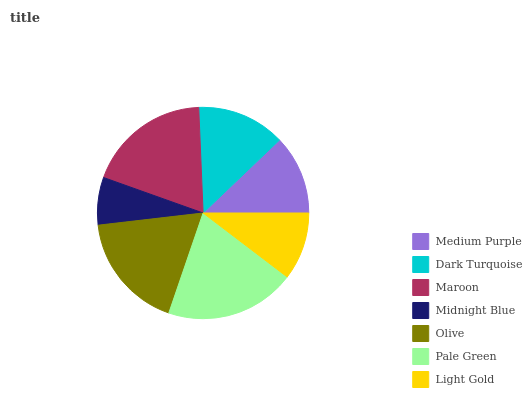Is Midnight Blue the minimum?
Answer yes or no. Yes. Is Pale Green the maximum?
Answer yes or no. Yes. Is Dark Turquoise the minimum?
Answer yes or no. No. Is Dark Turquoise the maximum?
Answer yes or no. No. Is Dark Turquoise greater than Medium Purple?
Answer yes or no. Yes. Is Medium Purple less than Dark Turquoise?
Answer yes or no. Yes. Is Medium Purple greater than Dark Turquoise?
Answer yes or no. No. Is Dark Turquoise less than Medium Purple?
Answer yes or no. No. Is Dark Turquoise the high median?
Answer yes or no. Yes. Is Dark Turquoise the low median?
Answer yes or no. Yes. Is Pale Green the high median?
Answer yes or no. No. Is Pale Green the low median?
Answer yes or no. No. 